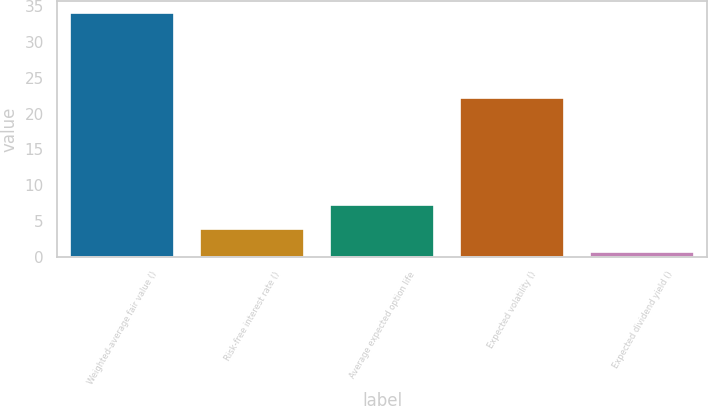Convert chart to OTSL. <chart><loc_0><loc_0><loc_500><loc_500><bar_chart><fcel>Weighted-average fair value ()<fcel>Risk-free interest rate ()<fcel>Average expected option life<fcel>Expected volatility ()<fcel>Expected dividend yield ()<nl><fcel>33.98<fcel>3.96<fcel>7.3<fcel>22.17<fcel>0.62<nl></chart> 